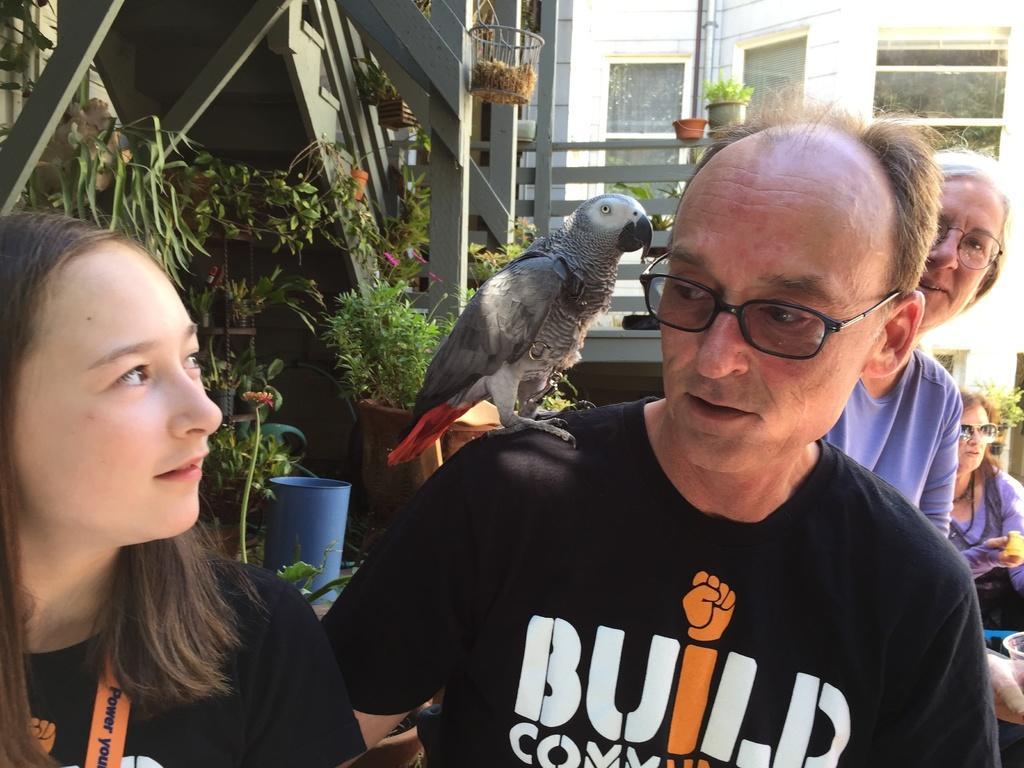Please provide a concise description of this image. In this image we can see people and a bird standing on the shoulders of one person. In the background we can see stairs, railings, flower pots and buildings. 